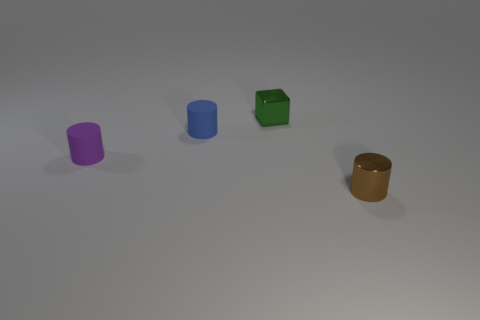What is the material of the purple cylinder that is the same size as the brown metal thing?
Your answer should be compact. Rubber. What number of objects are either tiny purple matte objects or metallic objects on the right side of the green object?
Offer a terse response. 2. How many balls are either tiny blue rubber things or green metallic things?
Give a very brief answer. 0. How many metallic things are both behind the brown metal cylinder and in front of the green cube?
Your answer should be compact. 0. What is the shape of the small thing behind the blue rubber object?
Keep it short and to the point. Cube. Does the blue thing have the same material as the small purple cylinder?
Ensure brevity in your answer.  Yes. What number of blue matte cylinders are on the left side of the tiny metal cylinder?
Keep it short and to the point. 1. What is the shape of the small metal thing that is behind the shiny thing to the right of the shiny cube?
Give a very brief answer. Cube. Is there anything else that has the same shape as the green object?
Offer a very short reply. No. Is the number of tiny cylinders that are behind the brown cylinder greater than the number of gray metal spheres?
Offer a very short reply. Yes. 